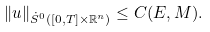Convert formula to latex. <formula><loc_0><loc_0><loc_500><loc_500>\| u \| _ { \dot { S } ^ { 0 } ( [ 0 , T ] \times \mathbb { R } ^ { n } ) } \leq C ( E , M ) .</formula> 